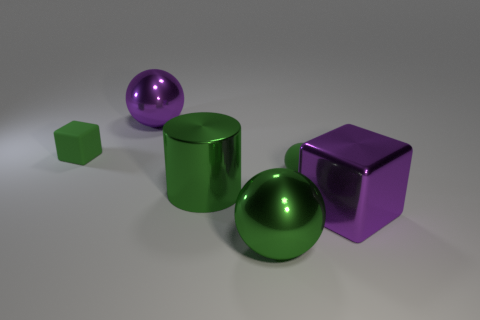How many objects are there, and can you describe their shapes and colors? There are five objects in total. Starting from the left, there is a small cube with a matte green surface, followed by a shiny purple sphere. Next is the vibrant green cylinder at the center. Moving right, there's a larger sphere with a reflective green surface similar to the cylinder. Finally, on the far right, there is a cube with a polished purple surface. 